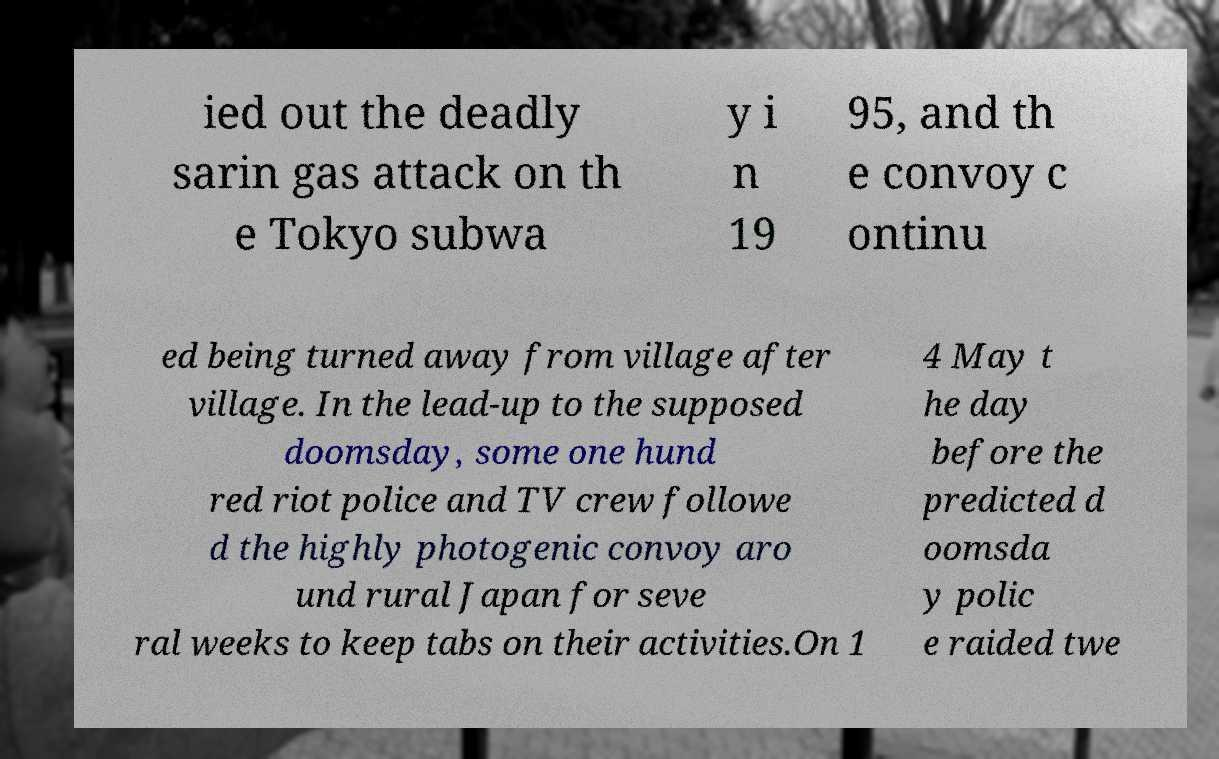Can you accurately transcribe the text from the provided image for me? ied out the deadly sarin gas attack on th e Tokyo subwa y i n 19 95, and th e convoy c ontinu ed being turned away from village after village. In the lead-up to the supposed doomsday, some one hund red riot police and TV crew followe d the highly photogenic convoy aro und rural Japan for seve ral weeks to keep tabs on their activities.On 1 4 May t he day before the predicted d oomsda y polic e raided twe 